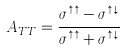Convert formula to latex. <formula><loc_0><loc_0><loc_500><loc_500>A _ { T T } = \frac { \sigma ^ { \uparrow \uparrow } - \sigma ^ { \uparrow \downarrow } } { \sigma ^ { \uparrow \uparrow } + \sigma ^ { \uparrow \downarrow } }</formula> 